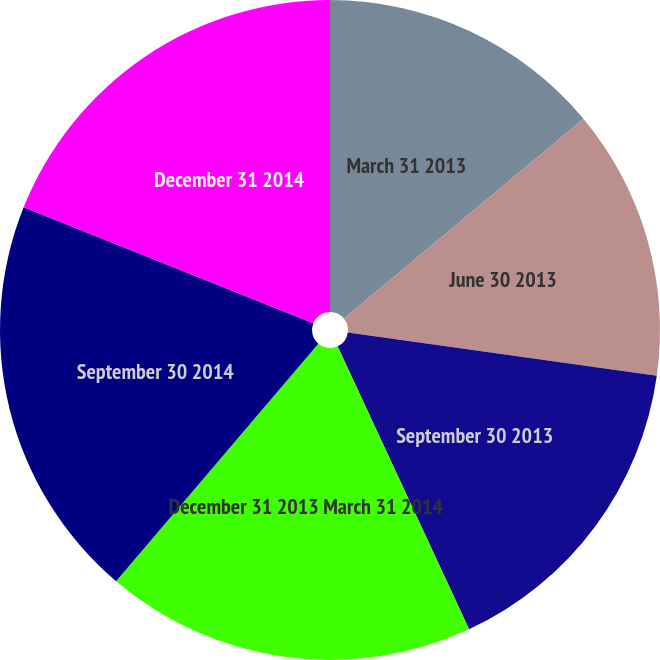Convert chart to OTSL. <chart><loc_0><loc_0><loc_500><loc_500><pie_chart><fcel>March 31 2013<fcel>June 30 2013<fcel>September 30 2013<fcel>December 31 2013 March 31 2014<fcel>September 30 2014<fcel>December 31 2014<nl><fcel>13.94%<fcel>13.28%<fcel>15.86%<fcel>18.15%<fcel>19.84%<fcel>18.94%<nl></chart> 